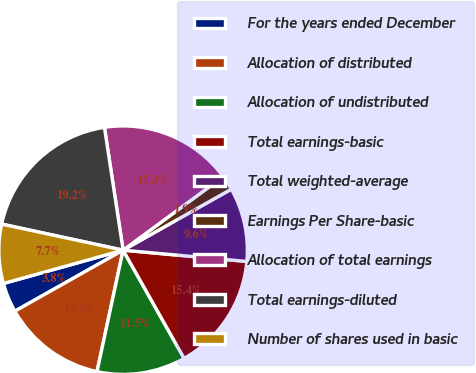Convert chart to OTSL. <chart><loc_0><loc_0><loc_500><loc_500><pie_chart><fcel>For the years ended December<fcel>Allocation of distributed<fcel>Allocation of undistributed<fcel>Total earnings-basic<fcel>Total weighted-average<fcel>Earnings Per Share-basic<fcel>Allocation of total earnings<fcel>Total earnings-diluted<fcel>Number of shares used in basic<nl><fcel>3.85%<fcel>13.46%<fcel>11.54%<fcel>15.38%<fcel>9.62%<fcel>1.92%<fcel>17.31%<fcel>19.23%<fcel>7.69%<nl></chart> 